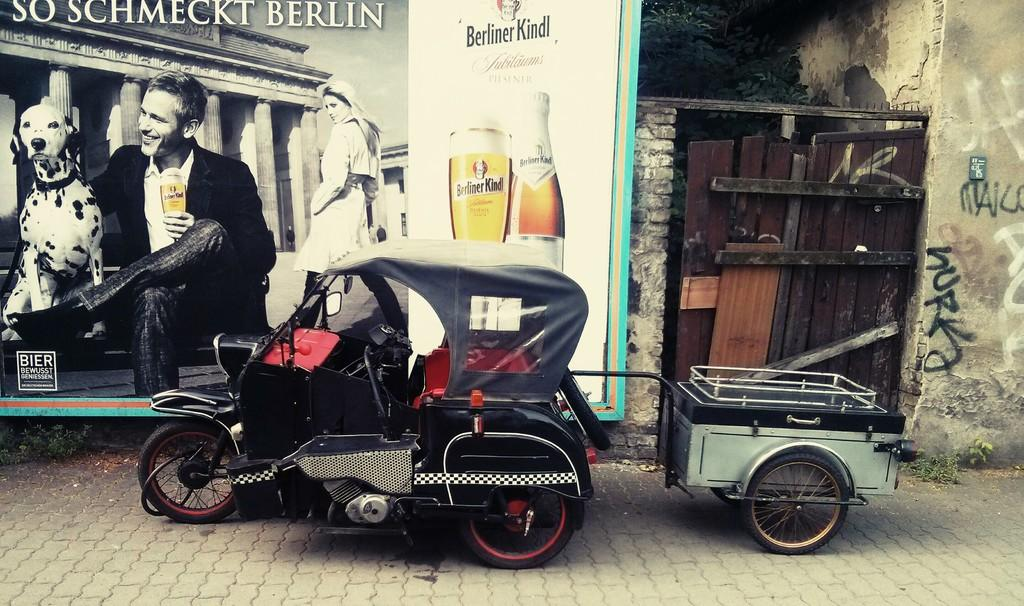What is the main subject in the image? There is a vehicle parked on a path in the image. What is located behind the vehicle? There is a banner with images and text behind the vehicle. What structure is beside the banner? There is a wooden gate of a building beside the banner. What type of pen is being used to write on the banner in the image? There is no pen visible in the image, and it is not possible to determine if one was used to write on the banner. 